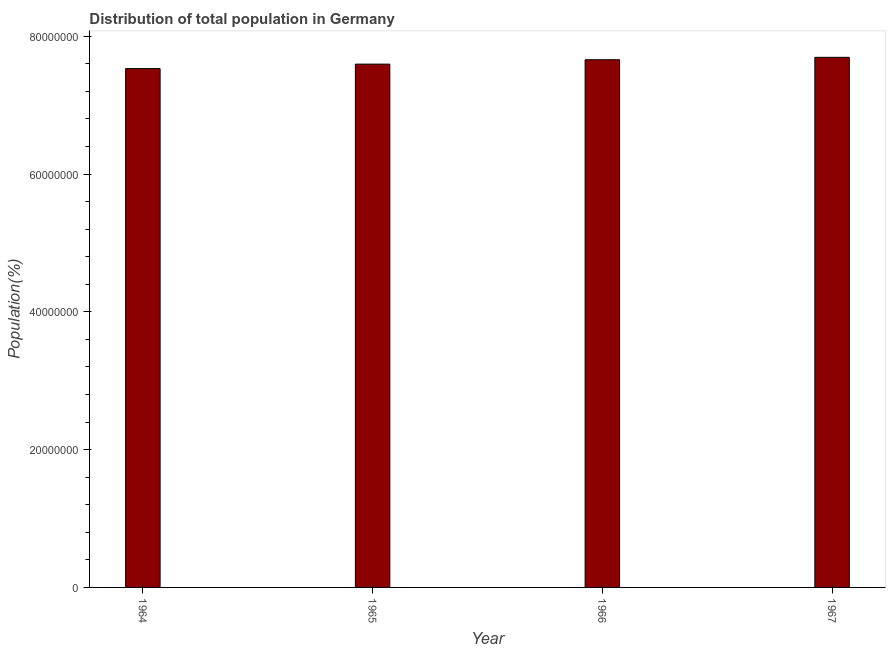What is the title of the graph?
Offer a very short reply. Distribution of total population in Germany . What is the label or title of the X-axis?
Your response must be concise. Year. What is the label or title of the Y-axis?
Offer a terse response. Population(%). What is the population in 1967?
Provide a succinct answer. 7.70e+07. Across all years, what is the maximum population?
Your answer should be compact. 7.70e+07. Across all years, what is the minimum population?
Your answer should be very brief. 7.53e+07. In which year was the population maximum?
Offer a terse response. 1967. In which year was the population minimum?
Make the answer very short. 1964. What is the sum of the population?
Your response must be concise. 3.05e+08. What is the difference between the population in 1965 and 1966?
Give a very brief answer. -6.37e+05. What is the average population per year?
Your response must be concise. 7.62e+07. What is the median population?
Give a very brief answer. 7.63e+07. Is the difference between the population in 1964 and 1965 greater than the difference between any two years?
Your answer should be compact. No. What is the difference between the highest and the second highest population?
Offer a very short reply. 3.51e+05. Is the sum of the population in 1965 and 1967 greater than the maximum population across all years?
Your response must be concise. Yes. What is the difference between the highest and the lowest population?
Keep it short and to the point. 1.63e+06. In how many years, is the population greater than the average population taken over all years?
Provide a succinct answer. 2. How many years are there in the graph?
Your answer should be very brief. 4. Are the values on the major ticks of Y-axis written in scientific E-notation?
Keep it short and to the point. No. What is the Population(%) of 1964?
Keep it short and to the point. 7.53e+07. What is the Population(%) in 1965?
Give a very brief answer. 7.60e+07. What is the Population(%) of 1966?
Your response must be concise. 7.66e+07. What is the Population(%) of 1967?
Your answer should be compact. 7.70e+07. What is the difference between the Population(%) in 1964 and 1965?
Your response must be concise. -6.45e+05. What is the difference between the Population(%) in 1964 and 1966?
Your response must be concise. -1.28e+06. What is the difference between the Population(%) in 1964 and 1967?
Offer a terse response. -1.63e+06. What is the difference between the Population(%) in 1965 and 1966?
Give a very brief answer. -6.37e+05. What is the difference between the Population(%) in 1965 and 1967?
Give a very brief answer. -9.88e+05. What is the difference between the Population(%) in 1966 and 1967?
Keep it short and to the point. -3.51e+05. What is the ratio of the Population(%) in 1964 to that in 1965?
Offer a terse response. 0.99. What is the ratio of the Population(%) in 1964 to that in 1967?
Your response must be concise. 0.98. What is the ratio of the Population(%) in 1966 to that in 1967?
Keep it short and to the point. 0.99. 